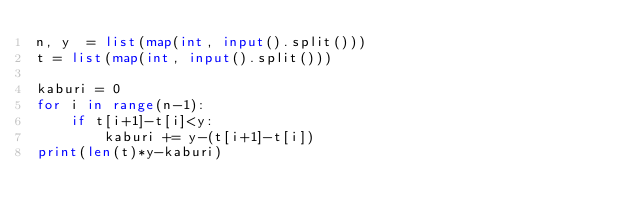Convert code to text. <code><loc_0><loc_0><loc_500><loc_500><_Python_>n, y  = list(map(int, input().split()))
t = list(map(int, input().split()))

kaburi = 0
for i in range(n-1):
    if t[i+1]-t[i]<y:
        kaburi += y-(t[i+1]-t[i])
print(len(t)*y-kaburi)
</code> 